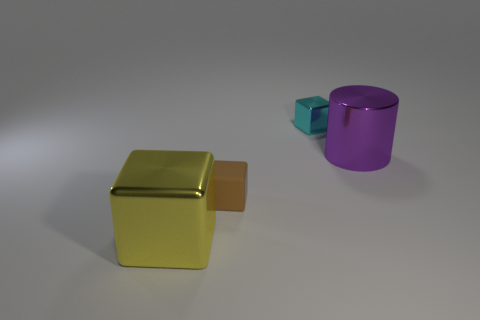Do the big object that is on the right side of the big metal block and the tiny object that is in front of the large purple cylinder have the same material?
Offer a very short reply. No. There is a small brown thing; what shape is it?
Your answer should be very brief. Cube. Are there more purple objects to the right of the yellow object than yellow shiny cubes on the right side of the brown block?
Your answer should be very brief. Yes. There is a tiny object that is right of the small brown thing; is its shape the same as the big thing to the right of the yellow thing?
Provide a succinct answer. No. What number of other objects are the same size as the matte object?
Your answer should be compact. 1. How big is the yellow cube?
Your answer should be compact. Large. Do the large object right of the big block and the brown cube have the same material?
Make the answer very short. No. There is another small object that is the same shape as the small brown thing; what color is it?
Your answer should be compact. Cyan. Are there any large things left of the cyan block?
Provide a succinct answer. Yes. What is the color of the shiny thing that is right of the big metal block and on the left side of the purple cylinder?
Give a very brief answer. Cyan. 